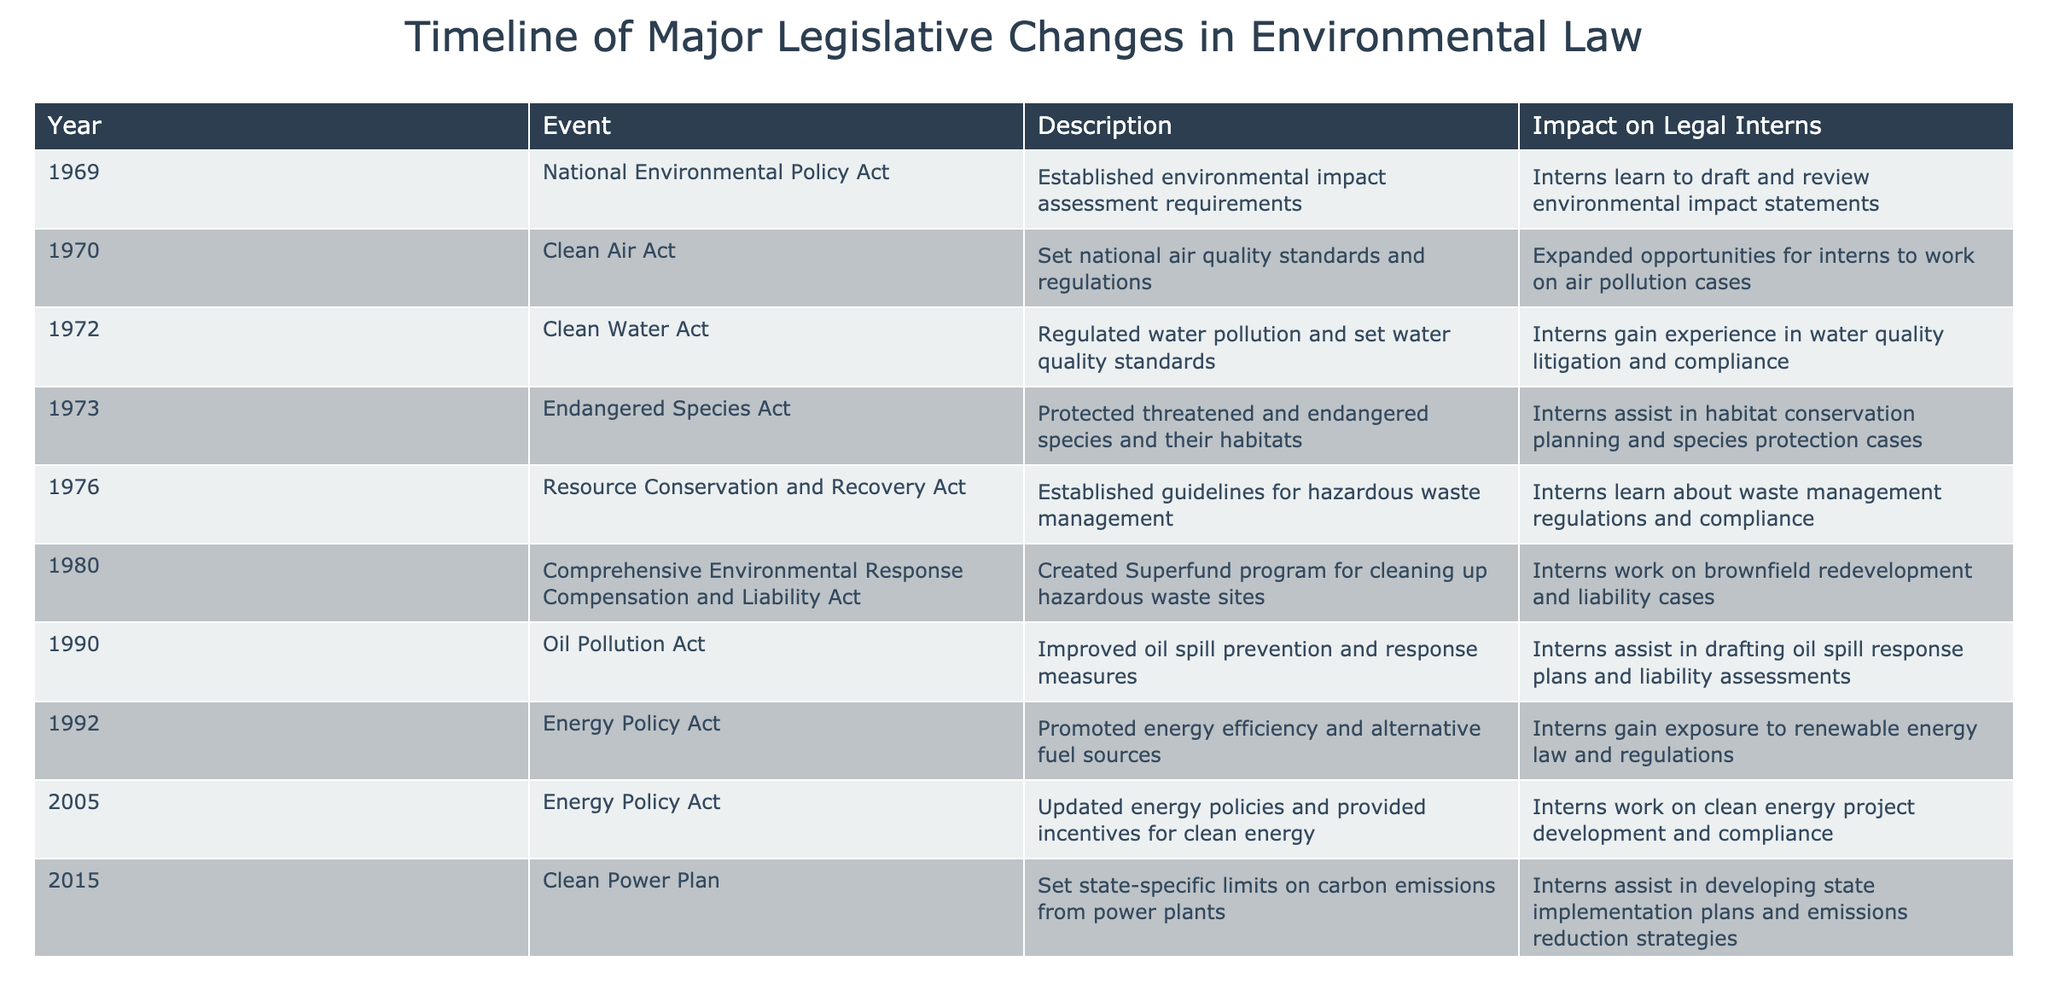What year was the Clean Air Act enacted? The Clean Air Act is listed in the table under the year 1970.
Answer: 1970 What impact did the Endangered Species Act have on interns? According to the table, interns assist in habitat conservation planning and species protection cases due to the Endangered Species Act.
Answer: Assist in habitat conservation planning and species protection cases How many years were there between the enactment of the Clean Water Act and the Oil Pollution Act? The Clean Water Act was enacted in 1972 and the Oil Pollution Act was enacted in 1990. The difference in years is 1990 - 1972 = 18 years.
Answer: 18 years Did the Comprehensive Environmental Response Compensation and Liability Act create the Superfund program? Yes, the table states that the Comprehensive Environmental Response Compensation and Liability Act created the Superfund program.
Answer: Yes Which event took place last in the timeline, and what was its impact on interns? The last event listed is the Navigable Waters Protection Rule in 2020. Its impact on interns is that they learn about regulatory changes and their impacts on wetland protection.
Answer: Navigable Waters Protection Rule; learn about regulatory changes and impacts on wetland protection How many pieces of legislation were enacted during the 1970s? The table shows five pieces of legislation enacted in the 1970s: National Environmental Policy Act (1969), Clean Air Act (1970), Clean Water Act (1972), Endangered Species Act (1973), and Resource Conservation and Recovery Act (1976). Thus, the correct count is five.
Answer: Five What was the main focus of the 2015 Clean Power Plan? The table indicates that the Clean Power Plan set state-specific limits on carbon emissions from power plants.
Answer: Set state-specific limits on carbon emissions from power plants How many acts specifically mention waste or pollution management? The Resource Conservation and Recovery Act (1976) and the Comprehensive Environmental Response Compensation and Liability Act (1980) both focus on waste management, while the Clean Water Act (1972) and Oil Pollution Act (1990) address pollution management, totaling four acts.
Answer: Four acts 